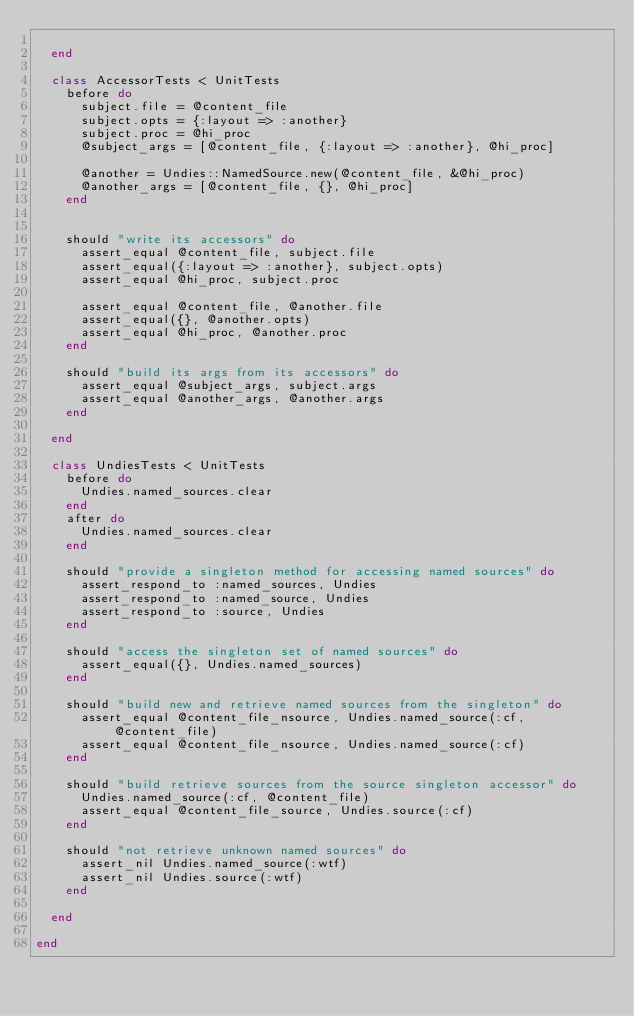Convert code to text. <code><loc_0><loc_0><loc_500><loc_500><_Ruby_>
  end

  class AccessorTests < UnitTests
    before do
      subject.file = @content_file
      subject.opts = {:layout => :another}
      subject.proc = @hi_proc
      @subject_args = [@content_file, {:layout => :another}, @hi_proc]

      @another = Undies::NamedSource.new(@content_file, &@hi_proc)
      @another_args = [@content_file, {}, @hi_proc]
    end


    should "write its accessors" do
      assert_equal @content_file, subject.file
      assert_equal({:layout => :another}, subject.opts)
      assert_equal @hi_proc, subject.proc

      assert_equal @content_file, @another.file
      assert_equal({}, @another.opts)
      assert_equal @hi_proc, @another.proc
    end

    should "build its args from its accessors" do
      assert_equal @subject_args, subject.args
      assert_equal @another_args, @another.args
    end

  end

  class UndiesTests < UnitTests
    before do
      Undies.named_sources.clear
    end
    after do
      Undies.named_sources.clear
    end

    should "provide a singleton method for accessing named sources" do
      assert_respond_to :named_sources, Undies
      assert_respond_to :named_source, Undies
      assert_respond_to :source, Undies
    end

    should "access the singleton set of named sources" do
      assert_equal({}, Undies.named_sources)
    end

    should "build new and retrieve named sources from the singleton" do
      assert_equal @content_file_nsource, Undies.named_source(:cf, @content_file)
      assert_equal @content_file_nsource, Undies.named_source(:cf)
    end

    should "build retrieve sources from the source singleton accessor" do
      Undies.named_source(:cf, @content_file)
      assert_equal @content_file_source, Undies.source(:cf)
    end

    should "not retrieve unknown named sources" do
      assert_nil Undies.named_source(:wtf)
      assert_nil Undies.source(:wtf)
    end

  end

end
</code> 